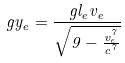Convert formula to latex. <formula><loc_0><loc_0><loc_500><loc_500>g y _ { e } = \frac { g l _ { e } v _ { e } } { \sqrt { 9 - \frac { v _ { e } ^ { 7 } } { c ^ { 7 } } } }</formula> 